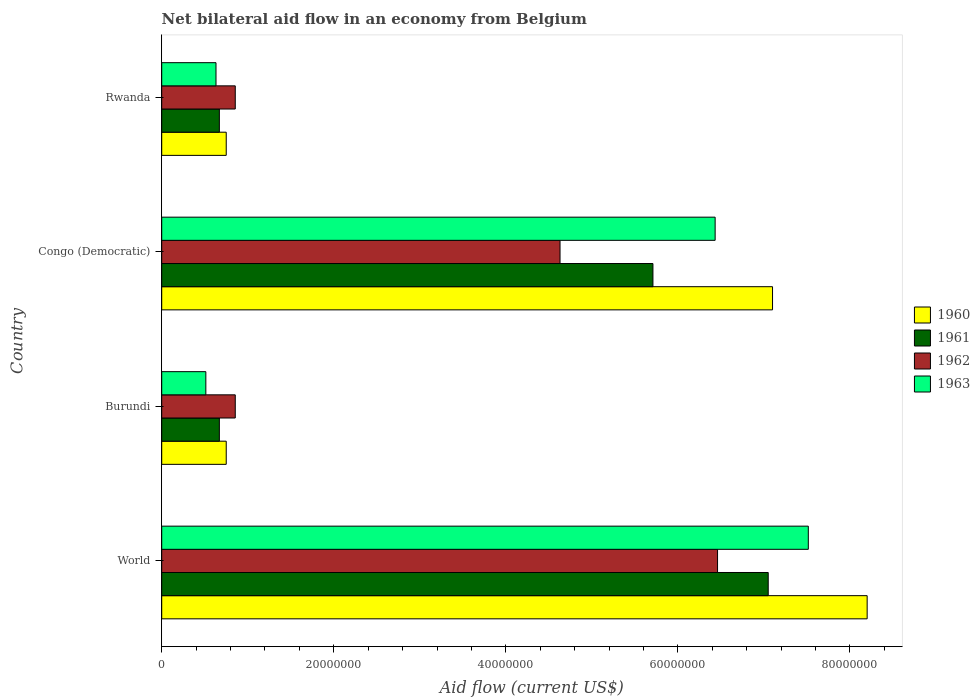How many different coloured bars are there?
Offer a very short reply. 4. Are the number of bars per tick equal to the number of legend labels?
Ensure brevity in your answer.  Yes. How many bars are there on the 1st tick from the top?
Your answer should be compact. 4. How many bars are there on the 2nd tick from the bottom?
Provide a short and direct response. 4. What is the label of the 1st group of bars from the top?
Provide a short and direct response. Rwanda. What is the net bilateral aid flow in 1962 in Congo (Democratic)?
Your answer should be compact. 4.63e+07. Across all countries, what is the maximum net bilateral aid flow in 1963?
Ensure brevity in your answer.  7.52e+07. Across all countries, what is the minimum net bilateral aid flow in 1961?
Your response must be concise. 6.70e+06. In which country was the net bilateral aid flow in 1963 minimum?
Give a very brief answer. Burundi. What is the total net bilateral aid flow in 1960 in the graph?
Your response must be concise. 1.68e+08. What is the difference between the net bilateral aid flow in 1962 in Congo (Democratic) and that in Rwanda?
Offer a very short reply. 3.78e+07. What is the difference between the net bilateral aid flow in 1961 in Congo (Democratic) and the net bilateral aid flow in 1962 in Rwanda?
Make the answer very short. 4.86e+07. What is the average net bilateral aid flow in 1963 per country?
Provide a short and direct response. 3.77e+07. What is the difference between the net bilateral aid flow in 1962 and net bilateral aid flow in 1960 in Congo (Democratic)?
Your answer should be very brief. -2.47e+07. What is the ratio of the net bilateral aid flow in 1960 in Congo (Democratic) to that in Rwanda?
Offer a terse response. 9.47. Is the net bilateral aid flow in 1961 in Burundi less than that in World?
Keep it short and to the point. Yes. What is the difference between the highest and the second highest net bilateral aid flow in 1961?
Your response must be concise. 1.34e+07. What is the difference between the highest and the lowest net bilateral aid flow in 1963?
Provide a succinct answer. 7.00e+07. In how many countries, is the net bilateral aid flow in 1960 greater than the average net bilateral aid flow in 1960 taken over all countries?
Your answer should be very brief. 2. Is the sum of the net bilateral aid flow in 1962 in Congo (Democratic) and World greater than the maximum net bilateral aid flow in 1961 across all countries?
Your answer should be compact. Yes. What does the 3rd bar from the top in Burundi represents?
Your answer should be very brief. 1961. What does the 3rd bar from the bottom in Burundi represents?
Make the answer very short. 1962. Is it the case that in every country, the sum of the net bilateral aid flow in 1962 and net bilateral aid flow in 1960 is greater than the net bilateral aid flow in 1961?
Your answer should be compact. Yes. Are all the bars in the graph horizontal?
Your answer should be compact. Yes. What is the difference between two consecutive major ticks on the X-axis?
Offer a very short reply. 2.00e+07. Are the values on the major ticks of X-axis written in scientific E-notation?
Offer a terse response. No. Does the graph contain any zero values?
Your answer should be very brief. No. Does the graph contain grids?
Your answer should be compact. No. Where does the legend appear in the graph?
Your answer should be compact. Center right. How many legend labels are there?
Provide a succinct answer. 4. How are the legend labels stacked?
Offer a terse response. Vertical. What is the title of the graph?
Give a very brief answer. Net bilateral aid flow in an economy from Belgium. Does "1973" appear as one of the legend labels in the graph?
Your answer should be compact. No. What is the label or title of the Y-axis?
Your answer should be very brief. Country. What is the Aid flow (current US$) in 1960 in World?
Offer a terse response. 8.20e+07. What is the Aid flow (current US$) in 1961 in World?
Provide a short and direct response. 7.05e+07. What is the Aid flow (current US$) of 1962 in World?
Give a very brief answer. 6.46e+07. What is the Aid flow (current US$) of 1963 in World?
Provide a succinct answer. 7.52e+07. What is the Aid flow (current US$) in 1960 in Burundi?
Provide a succinct answer. 7.50e+06. What is the Aid flow (current US$) in 1961 in Burundi?
Your answer should be very brief. 6.70e+06. What is the Aid flow (current US$) in 1962 in Burundi?
Ensure brevity in your answer.  8.55e+06. What is the Aid flow (current US$) of 1963 in Burundi?
Make the answer very short. 5.13e+06. What is the Aid flow (current US$) in 1960 in Congo (Democratic)?
Your answer should be very brief. 7.10e+07. What is the Aid flow (current US$) in 1961 in Congo (Democratic)?
Provide a short and direct response. 5.71e+07. What is the Aid flow (current US$) in 1962 in Congo (Democratic)?
Make the answer very short. 4.63e+07. What is the Aid flow (current US$) of 1963 in Congo (Democratic)?
Provide a succinct answer. 6.43e+07. What is the Aid flow (current US$) in 1960 in Rwanda?
Offer a very short reply. 7.50e+06. What is the Aid flow (current US$) in 1961 in Rwanda?
Offer a terse response. 6.70e+06. What is the Aid flow (current US$) in 1962 in Rwanda?
Make the answer very short. 8.55e+06. What is the Aid flow (current US$) in 1963 in Rwanda?
Your answer should be compact. 6.31e+06. Across all countries, what is the maximum Aid flow (current US$) in 1960?
Offer a terse response. 8.20e+07. Across all countries, what is the maximum Aid flow (current US$) in 1961?
Give a very brief answer. 7.05e+07. Across all countries, what is the maximum Aid flow (current US$) of 1962?
Provide a short and direct response. 6.46e+07. Across all countries, what is the maximum Aid flow (current US$) in 1963?
Your answer should be very brief. 7.52e+07. Across all countries, what is the minimum Aid flow (current US$) in 1960?
Provide a short and direct response. 7.50e+06. Across all countries, what is the minimum Aid flow (current US$) of 1961?
Offer a very short reply. 6.70e+06. Across all countries, what is the minimum Aid flow (current US$) of 1962?
Offer a very short reply. 8.55e+06. Across all countries, what is the minimum Aid flow (current US$) of 1963?
Ensure brevity in your answer.  5.13e+06. What is the total Aid flow (current US$) in 1960 in the graph?
Your answer should be very brief. 1.68e+08. What is the total Aid flow (current US$) in 1961 in the graph?
Provide a short and direct response. 1.41e+08. What is the total Aid flow (current US$) in 1962 in the graph?
Give a very brief answer. 1.28e+08. What is the total Aid flow (current US$) of 1963 in the graph?
Offer a terse response. 1.51e+08. What is the difference between the Aid flow (current US$) of 1960 in World and that in Burundi?
Your answer should be very brief. 7.45e+07. What is the difference between the Aid flow (current US$) of 1961 in World and that in Burundi?
Offer a very short reply. 6.38e+07. What is the difference between the Aid flow (current US$) in 1962 in World and that in Burundi?
Your answer should be very brief. 5.61e+07. What is the difference between the Aid flow (current US$) in 1963 in World and that in Burundi?
Provide a succinct answer. 7.00e+07. What is the difference between the Aid flow (current US$) of 1960 in World and that in Congo (Democratic)?
Give a very brief answer. 1.10e+07. What is the difference between the Aid flow (current US$) of 1961 in World and that in Congo (Democratic)?
Offer a very short reply. 1.34e+07. What is the difference between the Aid flow (current US$) in 1962 in World and that in Congo (Democratic)?
Offer a very short reply. 1.83e+07. What is the difference between the Aid flow (current US$) of 1963 in World and that in Congo (Democratic)?
Make the answer very short. 1.08e+07. What is the difference between the Aid flow (current US$) of 1960 in World and that in Rwanda?
Ensure brevity in your answer.  7.45e+07. What is the difference between the Aid flow (current US$) of 1961 in World and that in Rwanda?
Your answer should be compact. 6.38e+07. What is the difference between the Aid flow (current US$) of 1962 in World and that in Rwanda?
Make the answer very short. 5.61e+07. What is the difference between the Aid flow (current US$) of 1963 in World and that in Rwanda?
Make the answer very short. 6.88e+07. What is the difference between the Aid flow (current US$) of 1960 in Burundi and that in Congo (Democratic)?
Your response must be concise. -6.35e+07. What is the difference between the Aid flow (current US$) of 1961 in Burundi and that in Congo (Democratic)?
Provide a short and direct response. -5.04e+07. What is the difference between the Aid flow (current US$) in 1962 in Burundi and that in Congo (Democratic)?
Offer a very short reply. -3.78e+07. What is the difference between the Aid flow (current US$) in 1963 in Burundi and that in Congo (Democratic)?
Your answer should be very brief. -5.92e+07. What is the difference between the Aid flow (current US$) in 1960 in Burundi and that in Rwanda?
Your answer should be very brief. 0. What is the difference between the Aid flow (current US$) in 1961 in Burundi and that in Rwanda?
Ensure brevity in your answer.  0. What is the difference between the Aid flow (current US$) in 1963 in Burundi and that in Rwanda?
Your answer should be very brief. -1.18e+06. What is the difference between the Aid flow (current US$) in 1960 in Congo (Democratic) and that in Rwanda?
Give a very brief answer. 6.35e+07. What is the difference between the Aid flow (current US$) of 1961 in Congo (Democratic) and that in Rwanda?
Provide a short and direct response. 5.04e+07. What is the difference between the Aid flow (current US$) in 1962 in Congo (Democratic) and that in Rwanda?
Make the answer very short. 3.78e+07. What is the difference between the Aid flow (current US$) in 1963 in Congo (Democratic) and that in Rwanda?
Give a very brief answer. 5.80e+07. What is the difference between the Aid flow (current US$) of 1960 in World and the Aid flow (current US$) of 1961 in Burundi?
Provide a succinct answer. 7.53e+07. What is the difference between the Aid flow (current US$) of 1960 in World and the Aid flow (current US$) of 1962 in Burundi?
Offer a very short reply. 7.34e+07. What is the difference between the Aid flow (current US$) in 1960 in World and the Aid flow (current US$) in 1963 in Burundi?
Keep it short and to the point. 7.69e+07. What is the difference between the Aid flow (current US$) of 1961 in World and the Aid flow (current US$) of 1962 in Burundi?
Offer a terse response. 6.20e+07. What is the difference between the Aid flow (current US$) of 1961 in World and the Aid flow (current US$) of 1963 in Burundi?
Ensure brevity in your answer.  6.54e+07. What is the difference between the Aid flow (current US$) of 1962 in World and the Aid flow (current US$) of 1963 in Burundi?
Provide a short and direct response. 5.95e+07. What is the difference between the Aid flow (current US$) in 1960 in World and the Aid flow (current US$) in 1961 in Congo (Democratic)?
Your answer should be very brief. 2.49e+07. What is the difference between the Aid flow (current US$) of 1960 in World and the Aid flow (current US$) of 1962 in Congo (Democratic)?
Keep it short and to the point. 3.57e+07. What is the difference between the Aid flow (current US$) of 1960 in World and the Aid flow (current US$) of 1963 in Congo (Democratic)?
Your answer should be compact. 1.77e+07. What is the difference between the Aid flow (current US$) in 1961 in World and the Aid flow (current US$) in 1962 in Congo (Democratic)?
Your answer should be compact. 2.42e+07. What is the difference between the Aid flow (current US$) in 1961 in World and the Aid flow (current US$) in 1963 in Congo (Democratic)?
Your answer should be compact. 6.17e+06. What is the difference between the Aid flow (current US$) in 1960 in World and the Aid flow (current US$) in 1961 in Rwanda?
Your answer should be very brief. 7.53e+07. What is the difference between the Aid flow (current US$) in 1960 in World and the Aid flow (current US$) in 1962 in Rwanda?
Keep it short and to the point. 7.34e+07. What is the difference between the Aid flow (current US$) of 1960 in World and the Aid flow (current US$) of 1963 in Rwanda?
Ensure brevity in your answer.  7.57e+07. What is the difference between the Aid flow (current US$) of 1961 in World and the Aid flow (current US$) of 1962 in Rwanda?
Your answer should be compact. 6.20e+07. What is the difference between the Aid flow (current US$) in 1961 in World and the Aid flow (current US$) in 1963 in Rwanda?
Provide a succinct answer. 6.42e+07. What is the difference between the Aid flow (current US$) in 1962 in World and the Aid flow (current US$) in 1963 in Rwanda?
Offer a terse response. 5.83e+07. What is the difference between the Aid flow (current US$) in 1960 in Burundi and the Aid flow (current US$) in 1961 in Congo (Democratic)?
Your response must be concise. -4.96e+07. What is the difference between the Aid flow (current US$) of 1960 in Burundi and the Aid flow (current US$) of 1962 in Congo (Democratic)?
Offer a very short reply. -3.88e+07. What is the difference between the Aid flow (current US$) of 1960 in Burundi and the Aid flow (current US$) of 1963 in Congo (Democratic)?
Your answer should be very brief. -5.68e+07. What is the difference between the Aid flow (current US$) in 1961 in Burundi and the Aid flow (current US$) in 1962 in Congo (Democratic)?
Your answer should be compact. -3.96e+07. What is the difference between the Aid flow (current US$) of 1961 in Burundi and the Aid flow (current US$) of 1963 in Congo (Democratic)?
Ensure brevity in your answer.  -5.76e+07. What is the difference between the Aid flow (current US$) of 1962 in Burundi and the Aid flow (current US$) of 1963 in Congo (Democratic)?
Give a very brief answer. -5.58e+07. What is the difference between the Aid flow (current US$) in 1960 in Burundi and the Aid flow (current US$) in 1961 in Rwanda?
Provide a short and direct response. 8.00e+05. What is the difference between the Aid flow (current US$) in 1960 in Burundi and the Aid flow (current US$) in 1962 in Rwanda?
Offer a terse response. -1.05e+06. What is the difference between the Aid flow (current US$) of 1960 in Burundi and the Aid flow (current US$) of 1963 in Rwanda?
Ensure brevity in your answer.  1.19e+06. What is the difference between the Aid flow (current US$) of 1961 in Burundi and the Aid flow (current US$) of 1962 in Rwanda?
Ensure brevity in your answer.  -1.85e+06. What is the difference between the Aid flow (current US$) of 1961 in Burundi and the Aid flow (current US$) of 1963 in Rwanda?
Offer a very short reply. 3.90e+05. What is the difference between the Aid flow (current US$) of 1962 in Burundi and the Aid flow (current US$) of 1963 in Rwanda?
Give a very brief answer. 2.24e+06. What is the difference between the Aid flow (current US$) in 1960 in Congo (Democratic) and the Aid flow (current US$) in 1961 in Rwanda?
Make the answer very short. 6.43e+07. What is the difference between the Aid flow (current US$) in 1960 in Congo (Democratic) and the Aid flow (current US$) in 1962 in Rwanda?
Make the answer very short. 6.24e+07. What is the difference between the Aid flow (current US$) of 1960 in Congo (Democratic) and the Aid flow (current US$) of 1963 in Rwanda?
Your answer should be compact. 6.47e+07. What is the difference between the Aid flow (current US$) of 1961 in Congo (Democratic) and the Aid flow (current US$) of 1962 in Rwanda?
Your response must be concise. 4.86e+07. What is the difference between the Aid flow (current US$) of 1961 in Congo (Democratic) and the Aid flow (current US$) of 1963 in Rwanda?
Your response must be concise. 5.08e+07. What is the difference between the Aid flow (current US$) in 1962 in Congo (Democratic) and the Aid flow (current US$) in 1963 in Rwanda?
Keep it short and to the point. 4.00e+07. What is the average Aid flow (current US$) in 1960 per country?
Your answer should be very brief. 4.20e+07. What is the average Aid flow (current US$) in 1961 per country?
Keep it short and to the point. 3.52e+07. What is the average Aid flow (current US$) in 1962 per country?
Provide a short and direct response. 3.20e+07. What is the average Aid flow (current US$) in 1963 per country?
Provide a short and direct response. 3.77e+07. What is the difference between the Aid flow (current US$) of 1960 and Aid flow (current US$) of 1961 in World?
Your answer should be compact. 1.15e+07. What is the difference between the Aid flow (current US$) of 1960 and Aid flow (current US$) of 1962 in World?
Your answer should be very brief. 1.74e+07. What is the difference between the Aid flow (current US$) of 1960 and Aid flow (current US$) of 1963 in World?
Give a very brief answer. 6.84e+06. What is the difference between the Aid flow (current US$) in 1961 and Aid flow (current US$) in 1962 in World?
Make the answer very short. 5.89e+06. What is the difference between the Aid flow (current US$) of 1961 and Aid flow (current US$) of 1963 in World?
Offer a terse response. -4.66e+06. What is the difference between the Aid flow (current US$) of 1962 and Aid flow (current US$) of 1963 in World?
Offer a terse response. -1.06e+07. What is the difference between the Aid flow (current US$) in 1960 and Aid flow (current US$) in 1961 in Burundi?
Your answer should be compact. 8.00e+05. What is the difference between the Aid flow (current US$) in 1960 and Aid flow (current US$) in 1962 in Burundi?
Keep it short and to the point. -1.05e+06. What is the difference between the Aid flow (current US$) in 1960 and Aid flow (current US$) in 1963 in Burundi?
Provide a short and direct response. 2.37e+06. What is the difference between the Aid flow (current US$) in 1961 and Aid flow (current US$) in 1962 in Burundi?
Offer a very short reply. -1.85e+06. What is the difference between the Aid flow (current US$) of 1961 and Aid flow (current US$) of 1963 in Burundi?
Make the answer very short. 1.57e+06. What is the difference between the Aid flow (current US$) of 1962 and Aid flow (current US$) of 1963 in Burundi?
Offer a very short reply. 3.42e+06. What is the difference between the Aid flow (current US$) of 1960 and Aid flow (current US$) of 1961 in Congo (Democratic)?
Provide a short and direct response. 1.39e+07. What is the difference between the Aid flow (current US$) of 1960 and Aid flow (current US$) of 1962 in Congo (Democratic)?
Keep it short and to the point. 2.47e+07. What is the difference between the Aid flow (current US$) in 1960 and Aid flow (current US$) in 1963 in Congo (Democratic)?
Give a very brief answer. 6.67e+06. What is the difference between the Aid flow (current US$) of 1961 and Aid flow (current US$) of 1962 in Congo (Democratic)?
Give a very brief answer. 1.08e+07. What is the difference between the Aid flow (current US$) in 1961 and Aid flow (current US$) in 1963 in Congo (Democratic)?
Your answer should be compact. -7.23e+06. What is the difference between the Aid flow (current US$) of 1962 and Aid flow (current US$) of 1963 in Congo (Democratic)?
Give a very brief answer. -1.80e+07. What is the difference between the Aid flow (current US$) of 1960 and Aid flow (current US$) of 1961 in Rwanda?
Offer a terse response. 8.00e+05. What is the difference between the Aid flow (current US$) of 1960 and Aid flow (current US$) of 1962 in Rwanda?
Offer a very short reply. -1.05e+06. What is the difference between the Aid flow (current US$) of 1960 and Aid flow (current US$) of 1963 in Rwanda?
Give a very brief answer. 1.19e+06. What is the difference between the Aid flow (current US$) in 1961 and Aid flow (current US$) in 1962 in Rwanda?
Make the answer very short. -1.85e+06. What is the difference between the Aid flow (current US$) in 1961 and Aid flow (current US$) in 1963 in Rwanda?
Make the answer very short. 3.90e+05. What is the difference between the Aid flow (current US$) in 1962 and Aid flow (current US$) in 1963 in Rwanda?
Your answer should be very brief. 2.24e+06. What is the ratio of the Aid flow (current US$) in 1960 in World to that in Burundi?
Your answer should be very brief. 10.93. What is the ratio of the Aid flow (current US$) in 1961 in World to that in Burundi?
Offer a very short reply. 10.52. What is the ratio of the Aid flow (current US$) in 1962 in World to that in Burundi?
Your answer should be very brief. 7.56. What is the ratio of the Aid flow (current US$) of 1963 in World to that in Burundi?
Offer a terse response. 14.65. What is the ratio of the Aid flow (current US$) of 1960 in World to that in Congo (Democratic)?
Make the answer very short. 1.15. What is the ratio of the Aid flow (current US$) in 1961 in World to that in Congo (Democratic)?
Your answer should be compact. 1.23. What is the ratio of the Aid flow (current US$) in 1962 in World to that in Congo (Democratic)?
Provide a short and direct response. 1.4. What is the ratio of the Aid flow (current US$) in 1963 in World to that in Congo (Democratic)?
Make the answer very short. 1.17. What is the ratio of the Aid flow (current US$) of 1960 in World to that in Rwanda?
Keep it short and to the point. 10.93. What is the ratio of the Aid flow (current US$) in 1961 in World to that in Rwanda?
Make the answer very short. 10.52. What is the ratio of the Aid flow (current US$) in 1962 in World to that in Rwanda?
Your answer should be very brief. 7.56. What is the ratio of the Aid flow (current US$) of 1963 in World to that in Rwanda?
Offer a very short reply. 11.91. What is the ratio of the Aid flow (current US$) in 1960 in Burundi to that in Congo (Democratic)?
Your response must be concise. 0.11. What is the ratio of the Aid flow (current US$) in 1961 in Burundi to that in Congo (Democratic)?
Provide a succinct answer. 0.12. What is the ratio of the Aid flow (current US$) in 1962 in Burundi to that in Congo (Democratic)?
Provide a succinct answer. 0.18. What is the ratio of the Aid flow (current US$) in 1963 in Burundi to that in Congo (Democratic)?
Keep it short and to the point. 0.08. What is the ratio of the Aid flow (current US$) of 1960 in Burundi to that in Rwanda?
Make the answer very short. 1. What is the ratio of the Aid flow (current US$) of 1961 in Burundi to that in Rwanda?
Provide a succinct answer. 1. What is the ratio of the Aid flow (current US$) of 1962 in Burundi to that in Rwanda?
Your answer should be compact. 1. What is the ratio of the Aid flow (current US$) of 1963 in Burundi to that in Rwanda?
Your answer should be very brief. 0.81. What is the ratio of the Aid flow (current US$) of 1960 in Congo (Democratic) to that in Rwanda?
Provide a succinct answer. 9.47. What is the ratio of the Aid flow (current US$) in 1961 in Congo (Democratic) to that in Rwanda?
Ensure brevity in your answer.  8.52. What is the ratio of the Aid flow (current US$) in 1962 in Congo (Democratic) to that in Rwanda?
Offer a very short reply. 5.42. What is the ratio of the Aid flow (current US$) in 1963 in Congo (Democratic) to that in Rwanda?
Your answer should be compact. 10.19. What is the difference between the highest and the second highest Aid flow (current US$) in 1960?
Provide a succinct answer. 1.10e+07. What is the difference between the highest and the second highest Aid flow (current US$) in 1961?
Your response must be concise. 1.34e+07. What is the difference between the highest and the second highest Aid flow (current US$) in 1962?
Provide a succinct answer. 1.83e+07. What is the difference between the highest and the second highest Aid flow (current US$) of 1963?
Your response must be concise. 1.08e+07. What is the difference between the highest and the lowest Aid flow (current US$) in 1960?
Offer a very short reply. 7.45e+07. What is the difference between the highest and the lowest Aid flow (current US$) of 1961?
Provide a succinct answer. 6.38e+07. What is the difference between the highest and the lowest Aid flow (current US$) in 1962?
Offer a terse response. 5.61e+07. What is the difference between the highest and the lowest Aid flow (current US$) of 1963?
Keep it short and to the point. 7.00e+07. 